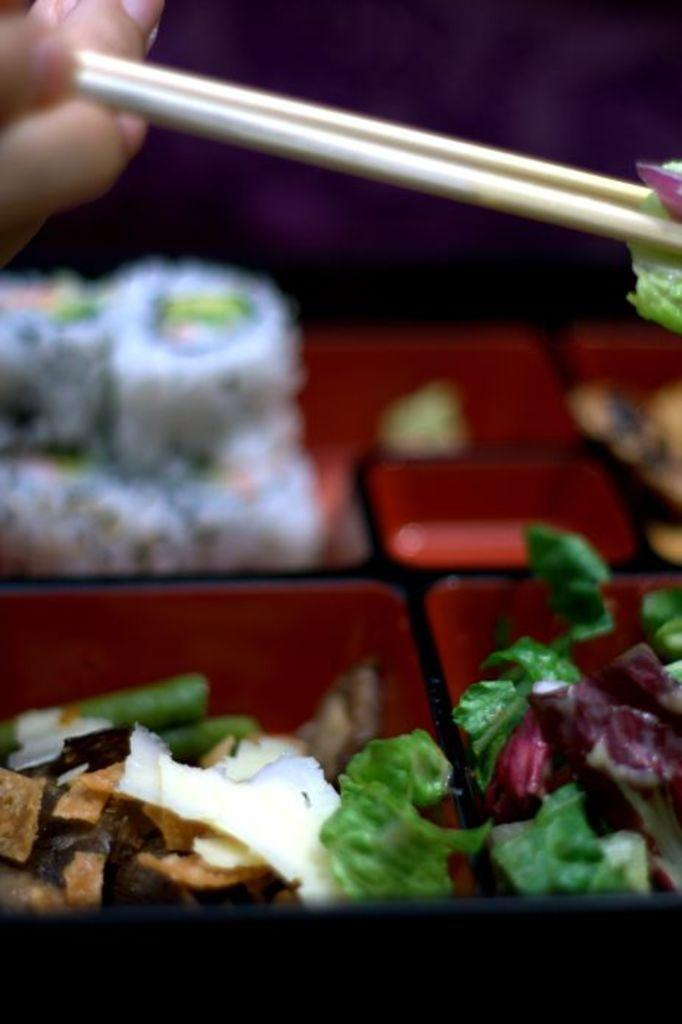What is inside the box that is visible in the image? There is a box with food items in the image. What utensil is being used to handle the food items? A person's hand is holding two chopsticks. What is the person's hand holding besides the chopsticks? The person's hand is holding a food item. What type of collar can be seen on the heart in the image? There is no heart or collar present in the image. 